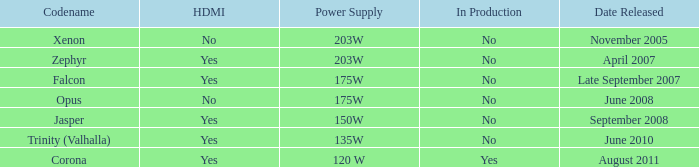Is Jasper being producted? No. 